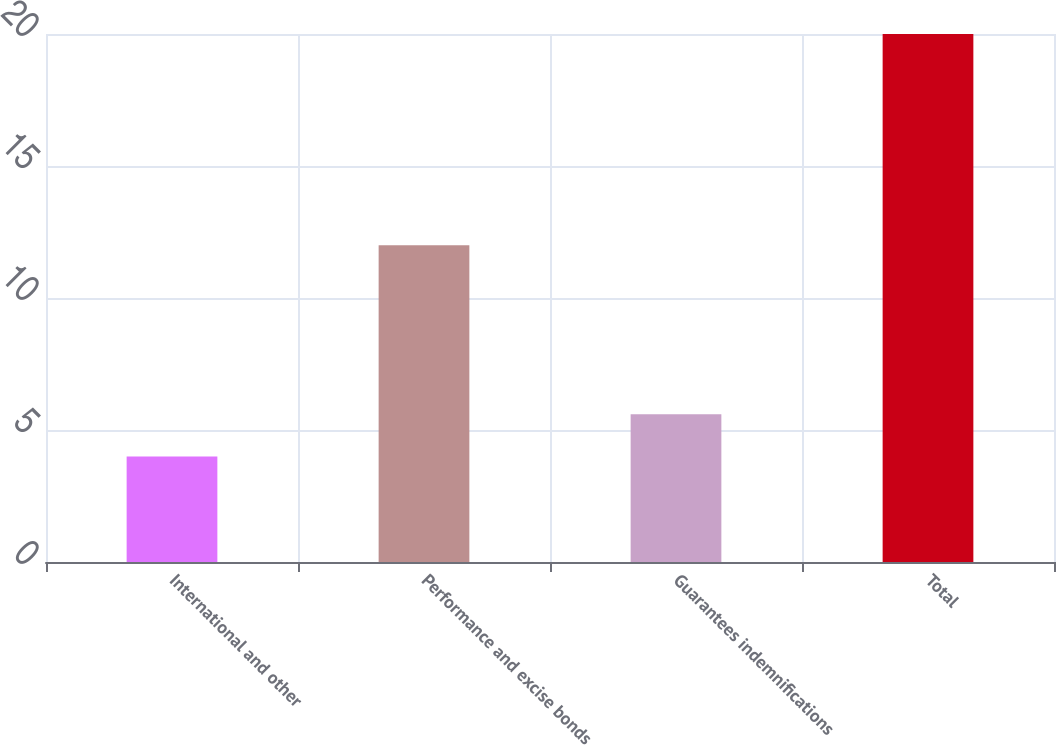Convert chart. <chart><loc_0><loc_0><loc_500><loc_500><bar_chart><fcel>International and other<fcel>Performance and excise bonds<fcel>Guarantees indemnifications<fcel>Total<nl><fcel>4<fcel>12<fcel>5.6<fcel>20<nl></chart> 